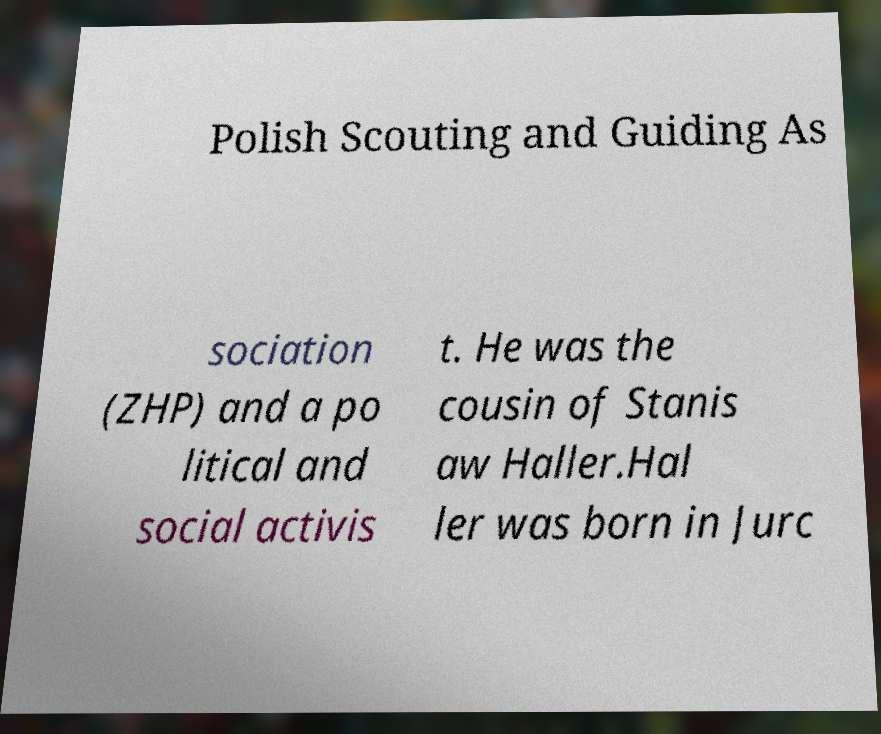Can you read and provide the text displayed in the image?This photo seems to have some interesting text. Can you extract and type it out for me? Polish Scouting and Guiding As sociation (ZHP) and a po litical and social activis t. He was the cousin of Stanis aw Haller.Hal ler was born in Jurc 